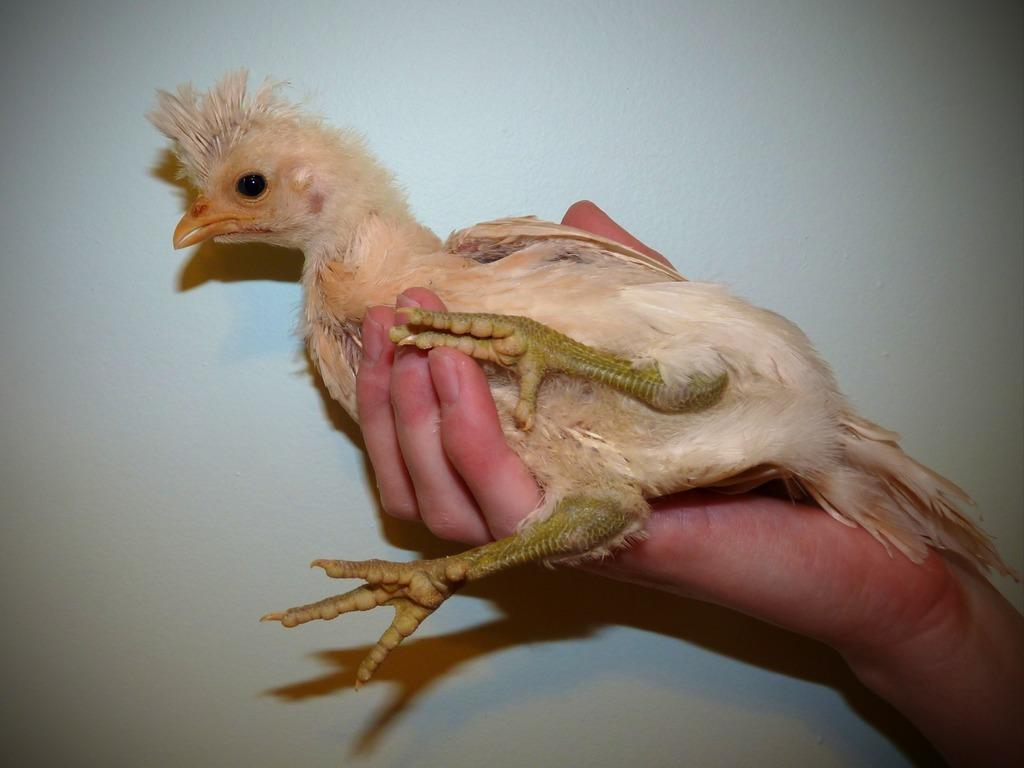What is the main subject of the image? There is a person in the image. What is the person doing in the image? The person is holding a bird in their hand. What can be seen in the background of the image? The background of the image is white. What type of scale can be seen in the image? There is no scale present in the image. What discovery was made by the person in the image? The image does not depict any discovery being made. 